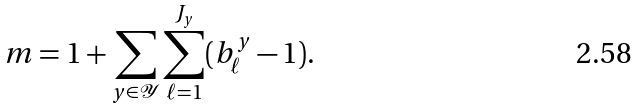Convert formula to latex. <formula><loc_0><loc_0><loc_500><loc_500>m = 1 + \sum _ { y \in \mathcal { Y } } \sum _ { \ell = 1 } ^ { J _ { y } } ( b ^ { y } _ { \ell } - 1 ) .</formula> 